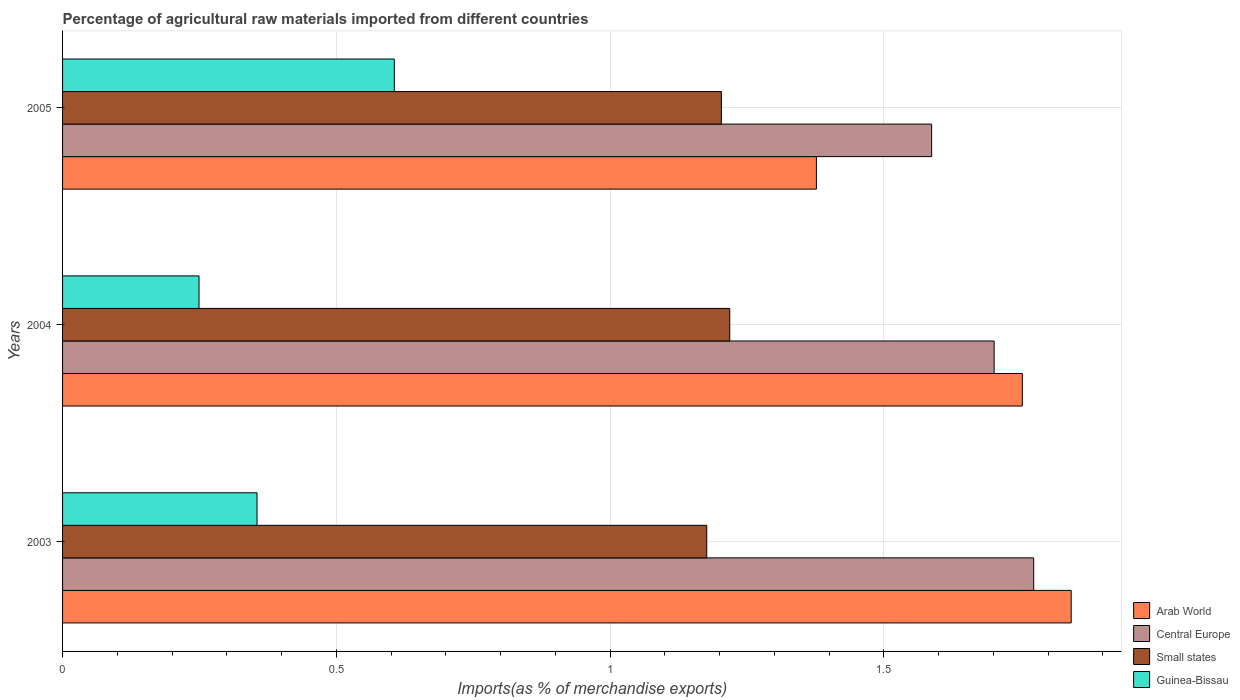How many different coloured bars are there?
Ensure brevity in your answer.  4. Are the number of bars per tick equal to the number of legend labels?
Provide a short and direct response. Yes. How many bars are there on the 3rd tick from the top?
Your response must be concise. 4. What is the percentage of imports to different countries in Guinea-Bissau in 2003?
Offer a very short reply. 0.36. Across all years, what is the maximum percentage of imports to different countries in Arab World?
Make the answer very short. 1.84. Across all years, what is the minimum percentage of imports to different countries in Guinea-Bissau?
Make the answer very short. 0.25. In which year was the percentage of imports to different countries in Arab World maximum?
Ensure brevity in your answer.  2003. In which year was the percentage of imports to different countries in Guinea-Bissau minimum?
Make the answer very short. 2004. What is the total percentage of imports to different countries in Small states in the graph?
Make the answer very short. 3.6. What is the difference between the percentage of imports to different countries in Small states in 2004 and that in 2005?
Keep it short and to the point. 0.02. What is the difference between the percentage of imports to different countries in Central Europe in 2004 and the percentage of imports to different countries in Guinea-Bissau in 2003?
Make the answer very short. 1.35. What is the average percentage of imports to different countries in Central Europe per year?
Your answer should be very brief. 1.69. In the year 2005, what is the difference between the percentage of imports to different countries in Arab World and percentage of imports to different countries in Central Europe?
Make the answer very short. -0.21. In how many years, is the percentage of imports to different countries in Central Europe greater than 1.8 %?
Give a very brief answer. 0. What is the ratio of the percentage of imports to different countries in Small states in 2004 to that in 2005?
Your response must be concise. 1.01. Is the percentage of imports to different countries in Small states in 2003 less than that in 2005?
Your answer should be very brief. Yes. What is the difference between the highest and the second highest percentage of imports to different countries in Central Europe?
Provide a short and direct response. 0.07. What is the difference between the highest and the lowest percentage of imports to different countries in Central Europe?
Offer a very short reply. 0.19. What does the 4th bar from the top in 2005 represents?
Make the answer very short. Arab World. What does the 4th bar from the bottom in 2005 represents?
Make the answer very short. Guinea-Bissau. Is it the case that in every year, the sum of the percentage of imports to different countries in Central Europe and percentage of imports to different countries in Arab World is greater than the percentage of imports to different countries in Small states?
Keep it short and to the point. Yes. Does the graph contain grids?
Offer a very short reply. Yes. What is the title of the graph?
Offer a terse response. Percentage of agricultural raw materials imported from different countries. What is the label or title of the X-axis?
Your answer should be compact. Imports(as % of merchandise exports). What is the Imports(as % of merchandise exports) in Arab World in 2003?
Give a very brief answer. 1.84. What is the Imports(as % of merchandise exports) in Central Europe in 2003?
Your answer should be very brief. 1.77. What is the Imports(as % of merchandise exports) of Small states in 2003?
Make the answer very short. 1.18. What is the Imports(as % of merchandise exports) in Guinea-Bissau in 2003?
Offer a terse response. 0.36. What is the Imports(as % of merchandise exports) of Arab World in 2004?
Offer a terse response. 1.75. What is the Imports(as % of merchandise exports) in Central Europe in 2004?
Offer a terse response. 1.7. What is the Imports(as % of merchandise exports) of Small states in 2004?
Your answer should be compact. 1.22. What is the Imports(as % of merchandise exports) of Guinea-Bissau in 2004?
Offer a very short reply. 0.25. What is the Imports(as % of merchandise exports) of Arab World in 2005?
Offer a terse response. 1.38. What is the Imports(as % of merchandise exports) in Central Europe in 2005?
Provide a short and direct response. 1.59. What is the Imports(as % of merchandise exports) of Small states in 2005?
Keep it short and to the point. 1.2. What is the Imports(as % of merchandise exports) of Guinea-Bissau in 2005?
Your answer should be very brief. 0.61. Across all years, what is the maximum Imports(as % of merchandise exports) in Arab World?
Your answer should be compact. 1.84. Across all years, what is the maximum Imports(as % of merchandise exports) of Central Europe?
Your answer should be very brief. 1.77. Across all years, what is the maximum Imports(as % of merchandise exports) of Small states?
Make the answer very short. 1.22. Across all years, what is the maximum Imports(as % of merchandise exports) in Guinea-Bissau?
Offer a very short reply. 0.61. Across all years, what is the minimum Imports(as % of merchandise exports) in Arab World?
Give a very brief answer. 1.38. Across all years, what is the minimum Imports(as % of merchandise exports) in Central Europe?
Your answer should be very brief. 1.59. Across all years, what is the minimum Imports(as % of merchandise exports) in Small states?
Your answer should be compact. 1.18. Across all years, what is the minimum Imports(as % of merchandise exports) in Guinea-Bissau?
Make the answer very short. 0.25. What is the total Imports(as % of merchandise exports) in Arab World in the graph?
Offer a very short reply. 4.97. What is the total Imports(as % of merchandise exports) of Central Europe in the graph?
Your answer should be compact. 5.06. What is the total Imports(as % of merchandise exports) of Small states in the graph?
Your answer should be very brief. 3.6. What is the total Imports(as % of merchandise exports) in Guinea-Bissau in the graph?
Your response must be concise. 1.21. What is the difference between the Imports(as % of merchandise exports) of Arab World in 2003 and that in 2004?
Provide a succinct answer. 0.09. What is the difference between the Imports(as % of merchandise exports) in Central Europe in 2003 and that in 2004?
Make the answer very short. 0.07. What is the difference between the Imports(as % of merchandise exports) in Small states in 2003 and that in 2004?
Offer a very short reply. -0.04. What is the difference between the Imports(as % of merchandise exports) of Guinea-Bissau in 2003 and that in 2004?
Offer a terse response. 0.11. What is the difference between the Imports(as % of merchandise exports) in Arab World in 2003 and that in 2005?
Your response must be concise. 0.47. What is the difference between the Imports(as % of merchandise exports) of Central Europe in 2003 and that in 2005?
Offer a very short reply. 0.19. What is the difference between the Imports(as % of merchandise exports) in Small states in 2003 and that in 2005?
Ensure brevity in your answer.  -0.03. What is the difference between the Imports(as % of merchandise exports) in Guinea-Bissau in 2003 and that in 2005?
Provide a succinct answer. -0.25. What is the difference between the Imports(as % of merchandise exports) of Arab World in 2004 and that in 2005?
Give a very brief answer. 0.38. What is the difference between the Imports(as % of merchandise exports) of Central Europe in 2004 and that in 2005?
Your answer should be compact. 0.11. What is the difference between the Imports(as % of merchandise exports) in Small states in 2004 and that in 2005?
Your answer should be compact. 0.02. What is the difference between the Imports(as % of merchandise exports) of Guinea-Bissau in 2004 and that in 2005?
Keep it short and to the point. -0.36. What is the difference between the Imports(as % of merchandise exports) of Arab World in 2003 and the Imports(as % of merchandise exports) of Central Europe in 2004?
Make the answer very short. 0.14. What is the difference between the Imports(as % of merchandise exports) in Arab World in 2003 and the Imports(as % of merchandise exports) in Small states in 2004?
Offer a terse response. 0.62. What is the difference between the Imports(as % of merchandise exports) of Arab World in 2003 and the Imports(as % of merchandise exports) of Guinea-Bissau in 2004?
Provide a short and direct response. 1.59. What is the difference between the Imports(as % of merchandise exports) in Central Europe in 2003 and the Imports(as % of merchandise exports) in Small states in 2004?
Your answer should be very brief. 0.56. What is the difference between the Imports(as % of merchandise exports) in Central Europe in 2003 and the Imports(as % of merchandise exports) in Guinea-Bissau in 2004?
Your response must be concise. 1.52. What is the difference between the Imports(as % of merchandise exports) in Small states in 2003 and the Imports(as % of merchandise exports) in Guinea-Bissau in 2004?
Keep it short and to the point. 0.93. What is the difference between the Imports(as % of merchandise exports) of Arab World in 2003 and the Imports(as % of merchandise exports) of Central Europe in 2005?
Your response must be concise. 0.25. What is the difference between the Imports(as % of merchandise exports) of Arab World in 2003 and the Imports(as % of merchandise exports) of Small states in 2005?
Ensure brevity in your answer.  0.64. What is the difference between the Imports(as % of merchandise exports) of Arab World in 2003 and the Imports(as % of merchandise exports) of Guinea-Bissau in 2005?
Provide a short and direct response. 1.24. What is the difference between the Imports(as % of merchandise exports) of Central Europe in 2003 and the Imports(as % of merchandise exports) of Small states in 2005?
Give a very brief answer. 0.57. What is the difference between the Imports(as % of merchandise exports) in Central Europe in 2003 and the Imports(as % of merchandise exports) in Guinea-Bissau in 2005?
Give a very brief answer. 1.17. What is the difference between the Imports(as % of merchandise exports) of Small states in 2003 and the Imports(as % of merchandise exports) of Guinea-Bissau in 2005?
Your answer should be very brief. 0.57. What is the difference between the Imports(as % of merchandise exports) of Arab World in 2004 and the Imports(as % of merchandise exports) of Central Europe in 2005?
Give a very brief answer. 0.17. What is the difference between the Imports(as % of merchandise exports) in Arab World in 2004 and the Imports(as % of merchandise exports) in Small states in 2005?
Give a very brief answer. 0.55. What is the difference between the Imports(as % of merchandise exports) of Arab World in 2004 and the Imports(as % of merchandise exports) of Guinea-Bissau in 2005?
Provide a succinct answer. 1.15. What is the difference between the Imports(as % of merchandise exports) of Central Europe in 2004 and the Imports(as % of merchandise exports) of Small states in 2005?
Provide a succinct answer. 0.5. What is the difference between the Imports(as % of merchandise exports) of Central Europe in 2004 and the Imports(as % of merchandise exports) of Guinea-Bissau in 2005?
Make the answer very short. 1.1. What is the difference between the Imports(as % of merchandise exports) in Small states in 2004 and the Imports(as % of merchandise exports) in Guinea-Bissau in 2005?
Make the answer very short. 0.61. What is the average Imports(as % of merchandise exports) in Arab World per year?
Provide a short and direct response. 1.66. What is the average Imports(as % of merchandise exports) of Central Europe per year?
Provide a short and direct response. 1.69. What is the average Imports(as % of merchandise exports) in Small states per year?
Ensure brevity in your answer.  1.2. What is the average Imports(as % of merchandise exports) of Guinea-Bissau per year?
Provide a succinct answer. 0.4. In the year 2003, what is the difference between the Imports(as % of merchandise exports) in Arab World and Imports(as % of merchandise exports) in Central Europe?
Provide a succinct answer. 0.07. In the year 2003, what is the difference between the Imports(as % of merchandise exports) of Arab World and Imports(as % of merchandise exports) of Small states?
Offer a terse response. 0.67. In the year 2003, what is the difference between the Imports(as % of merchandise exports) in Arab World and Imports(as % of merchandise exports) in Guinea-Bissau?
Your response must be concise. 1.49. In the year 2003, what is the difference between the Imports(as % of merchandise exports) in Central Europe and Imports(as % of merchandise exports) in Small states?
Your answer should be very brief. 0.6. In the year 2003, what is the difference between the Imports(as % of merchandise exports) in Central Europe and Imports(as % of merchandise exports) in Guinea-Bissau?
Keep it short and to the point. 1.42. In the year 2003, what is the difference between the Imports(as % of merchandise exports) of Small states and Imports(as % of merchandise exports) of Guinea-Bissau?
Offer a terse response. 0.82. In the year 2004, what is the difference between the Imports(as % of merchandise exports) of Arab World and Imports(as % of merchandise exports) of Central Europe?
Your response must be concise. 0.05. In the year 2004, what is the difference between the Imports(as % of merchandise exports) of Arab World and Imports(as % of merchandise exports) of Small states?
Keep it short and to the point. 0.53. In the year 2004, what is the difference between the Imports(as % of merchandise exports) in Arab World and Imports(as % of merchandise exports) in Guinea-Bissau?
Provide a short and direct response. 1.5. In the year 2004, what is the difference between the Imports(as % of merchandise exports) of Central Europe and Imports(as % of merchandise exports) of Small states?
Keep it short and to the point. 0.48. In the year 2004, what is the difference between the Imports(as % of merchandise exports) of Central Europe and Imports(as % of merchandise exports) of Guinea-Bissau?
Your answer should be compact. 1.45. In the year 2004, what is the difference between the Imports(as % of merchandise exports) of Small states and Imports(as % of merchandise exports) of Guinea-Bissau?
Provide a short and direct response. 0.97. In the year 2005, what is the difference between the Imports(as % of merchandise exports) of Arab World and Imports(as % of merchandise exports) of Central Europe?
Make the answer very short. -0.21. In the year 2005, what is the difference between the Imports(as % of merchandise exports) in Arab World and Imports(as % of merchandise exports) in Small states?
Provide a short and direct response. 0.17. In the year 2005, what is the difference between the Imports(as % of merchandise exports) in Arab World and Imports(as % of merchandise exports) in Guinea-Bissau?
Offer a terse response. 0.77. In the year 2005, what is the difference between the Imports(as % of merchandise exports) in Central Europe and Imports(as % of merchandise exports) in Small states?
Offer a very short reply. 0.38. In the year 2005, what is the difference between the Imports(as % of merchandise exports) in Central Europe and Imports(as % of merchandise exports) in Guinea-Bissau?
Ensure brevity in your answer.  0.98. In the year 2005, what is the difference between the Imports(as % of merchandise exports) of Small states and Imports(as % of merchandise exports) of Guinea-Bissau?
Make the answer very short. 0.6. What is the ratio of the Imports(as % of merchandise exports) of Arab World in 2003 to that in 2004?
Your response must be concise. 1.05. What is the ratio of the Imports(as % of merchandise exports) in Central Europe in 2003 to that in 2004?
Provide a short and direct response. 1.04. What is the ratio of the Imports(as % of merchandise exports) in Small states in 2003 to that in 2004?
Offer a very short reply. 0.97. What is the ratio of the Imports(as % of merchandise exports) in Guinea-Bissau in 2003 to that in 2004?
Give a very brief answer. 1.43. What is the ratio of the Imports(as % of merchandise exports) of Arab World in 2003 to that in 2005?
Your answer should be very brief. 1.34. What is the ratio of the Imports(as % of merchandise exports) of Central Europe in 2003 to that in 2005?
Offer a terse response. 1.12. What is the ratio of the Imports(as % of merchandise exports) in Small states in 2003 to that in 2005?
Your answer should be very brief. 0.98. What is the ratio of the Imports(as % of merchandise exports) of Guinea-Bissau in 2003 to that in 2005?
Keep it short and to the point. 0.59. What is the ratio of the Imports(as % of merchandise exports) in Arab World in 2004 to that in 2005?
Provide a short and direct response. 1.27. What is the ratio of the Imports(as % of merchandise exports) in Central Europe in 2004 to that in 2005?
Offer a very short reply. 1.07. What is the ratio of the Imports(as % of merchandise exports) in Small states in 2004 to that in 2005?
Provide a succinct answer. 1.01. What is the ratio of the Imports(as % of merchandise exports) of Guinea-Bissau in 2004 to that in 2005?
Your response must be concise. 0.41. What is the difference between the highest and the second highest Imports(as % of merchandise exports) in Arab World?
Your answer should be very brief. 0.09. What is the difference between the highest and the second highest Imports(as % of merchandise exports) in Central Europe?
Make the answer very short. 0.07. What is the difference between the highest and the second highest Imports(as % of merchandise exports) of Small states?
Give a very brief answer. 0.02. What is the difference between the highest and the second highest Imports(as % of merchandise exports) of Guinea-Bissau?
Ensure brevity in your answer.  0.25. What is the difference between the highest and the lowest Imports(as % of merchandise exports) in Arab World?
Offer a very short reply. 0.47. What is the difference between the highest and the lowest Imports(as % of merchandise exports) of Central Europe?
Provide a succinct answer. 0.19. What is the difference between the highest and the lowest Imports(as % of merchandise exports) in Small states?
Your answer should be very brief. 0.04. What is the difference between the highest and the lowest Imports(as % of merchandise exports) in Guinea-Bissau?
Offer a very short reply. 0.36. 